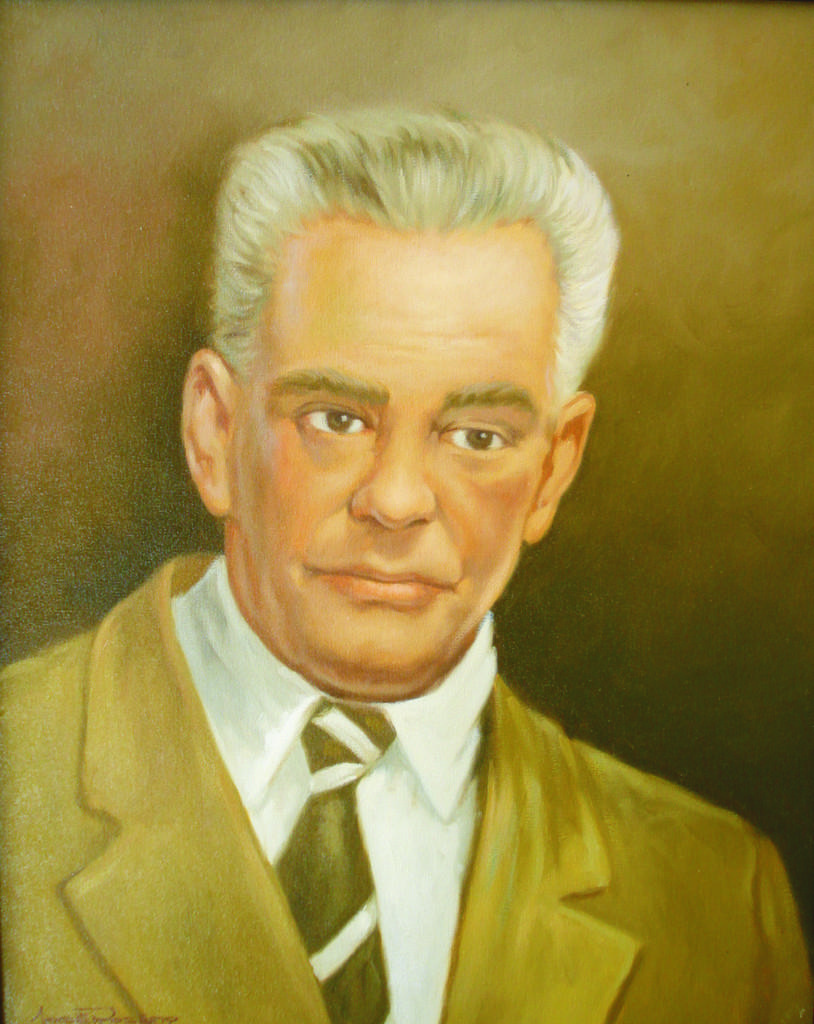What type of artwork is shown in the image? The image is a painting. What is the main subject of the painting? The painting depicts a man. What color is the tie the man is wearing? The man is wearing a black color tie. What color is the shirt the man is wearing? The man is wearing a white color shirt. What color is the jacket the man is wearing? The man is wearing a green color jacket. How much money does the man need to pay for the class in the image? There is no indication of a class or payment in the image; it is a painting of a man wearing a black tie, white shirt, and green jacket. 